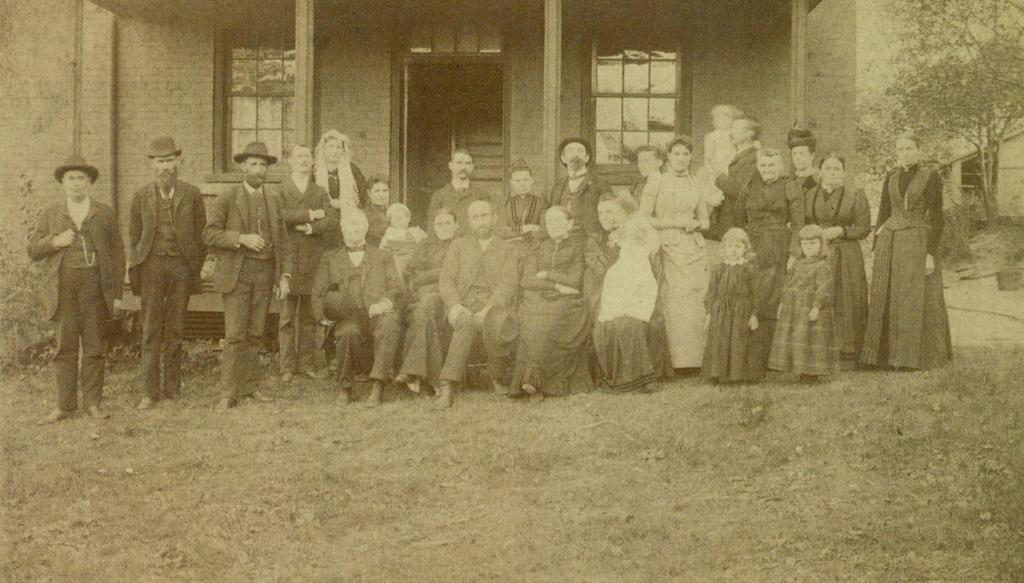What are the people in the image doing? The people in the image are standing and sitting. What can be seen in the background of the image? There is a building and trees in the background of the image. What type of vegetation is visible at the bottom of the image? There is grass at the bottom of the image. What is the people in the image writing on the grass? There is no writing or any indication of writing in the image; the people are simply standing or sitting. 